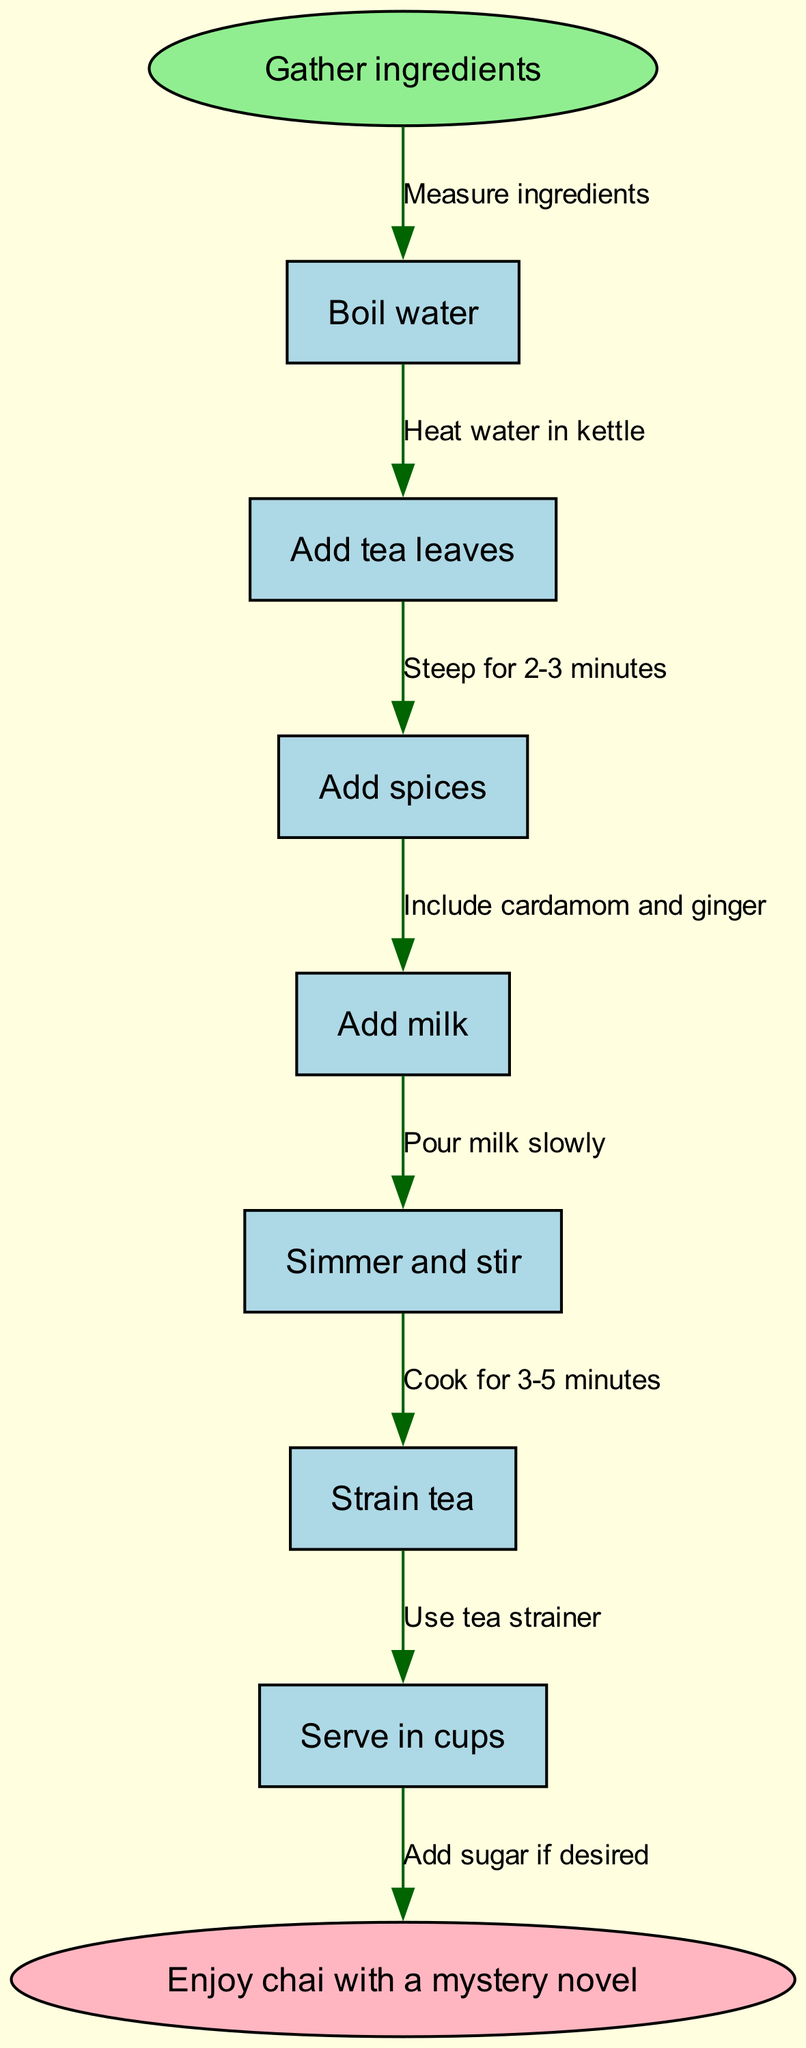What is the starting point of the chai tea making process? The flowchart clearly indicates that the starting point is labeled as "Gather ingredients". This is where the process begins.
Answer: Gather ingredients How many total nodes are in the diagram? The diagram has a total of 8 nodes: 1 start node, 6 process nodes, and 1 end node. Counting them gives us 8 in total.
Answer: 8 What are the last ingredients added in the process? From the flow of the diagram, the last step before serving is "Add milk", which is the final ingredient added before straining the tea.
Answer: Add milk What is the final action shown in the diagram? The flowchart ends with the node labeled "Enjoy chai with a mystery novel", which describes the final action once the tea is prepared.
Answer: Enjoy chai with a mystery novel What process follows boiling the water? The diagram shows that after "Boil water", the next step is labeled "Add tea leaves", indicating what comes next in the process.
Answer: Add tea leaves What is included with the tea leaves for flavor? The diagram specifies that "Add spices" is the following step after the tea leaves, which denotes the inclusion of spices such as cardamom and ginger.
Answer: Add spices How long should the tea be simmered for? According to the diagram, tea should be simmered for "3-5 minutes" as indicated in the edge leading from "Simmer and stir" to the next step.
Answer: 3-5 minutes What is added after straining the tea if desired? The chart shows an arrow leading from "Strain tea" to an action that states "Add sugar if desired", confirming that sugar is optional after straining.
Answer: Add sugar if desired 